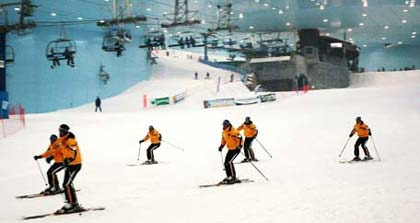Can you describe the actions of the skiers? The skiers are actively skiing down a snowy slope. They are in a typical skiing stance, with bent knees and a slight lean forward. They use their ski poles for balance and to aid their movement. The general motion suggests they are navigating the slope with controlled movements. 